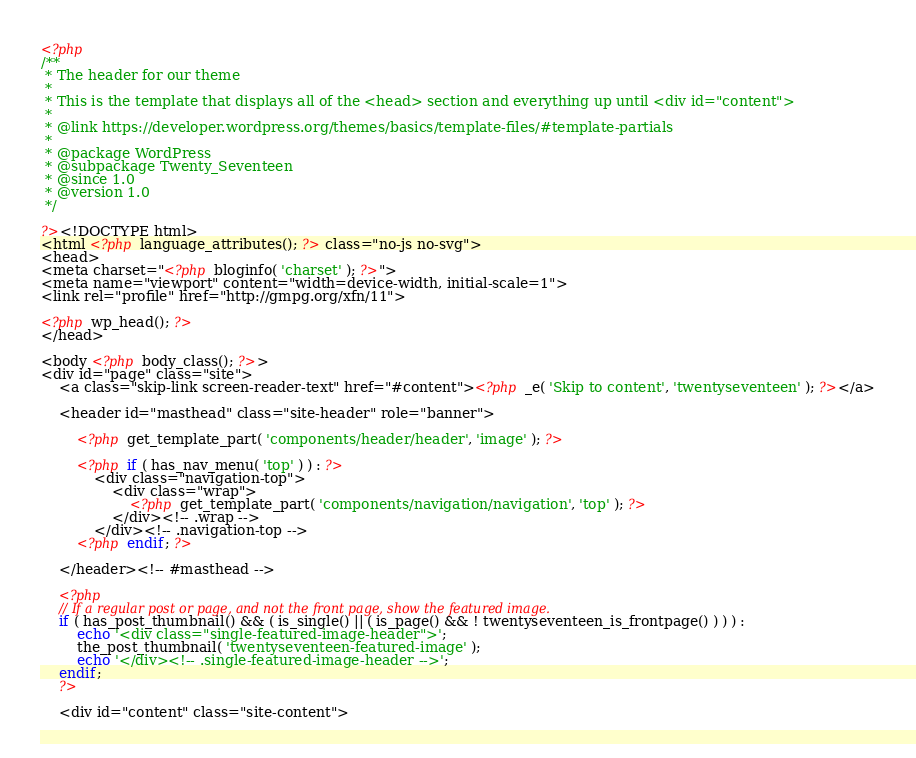Convert code to text. <code><loc_0><loc_0><loc_500><loc_500><_PHP_><?php
/**
 * The header for our theme
 *
 * This is the template that displays all of the <head> section and everything up until <div id="content">
 *
 * @link https://developer.wordpress.org/themes/basics/template-files/#template-partials
 *
 * @package WordPress
 * @subpackage Twenty_Seventeen
 * @since 1.0
 * @version 1.0
 */

?><!DOCTYPE html>
<html <?php language_attributes(); ?> class="no-js no-svg">
<head>
<meta charset="<?php bloginfo( 'charset' ); ?>">
<meta name="viewport" content="width=device-width, initial-scale=1">
<link rel="profile" href="http://gmpg.org/xfn/11">

<?php wp_head(); ?>
</head>

<body <?php body_class(); ?>>
<div id="page" class="site">
	<a class="skip-link screen-reader-text" href="#content"><?php _e( 'Skip to content', 'twentyseventeen' ); ?></a>

	<header id="masthead" class="site-header" role="banner">

		<?php get_template_part( 'components/header/header', 'image' ); ?>

		<?php if ( has_nav_menu( 'top' ) ) : ?>
			<div class="navigation-top">
				<div class="wrap">
					<?php get_template_part( 'components/navigation/navigation', 'top' ); ?>
				</div><!-- .wrap -->
			</div><!-- .navigation-top -->
		<?php endif; ?>

	</header><!-- #masthead -->

	<?php
	// If a regular post or page, and not the front page, show the featured image.
	if ( has_post_thumbnail() && ( is_single() || ( is_page() && ! twentyseventeen_is_frontpage() ) ) ) :
		echo '<div class="single-featured-image-header">';
		the_post_thumbnail( 'twentyseventeen-featured-image' );
		echo '</div><!-- .single-featured-image-header -->';
	endif;
	?>

	<div id="content" class="site-content">
</code> 